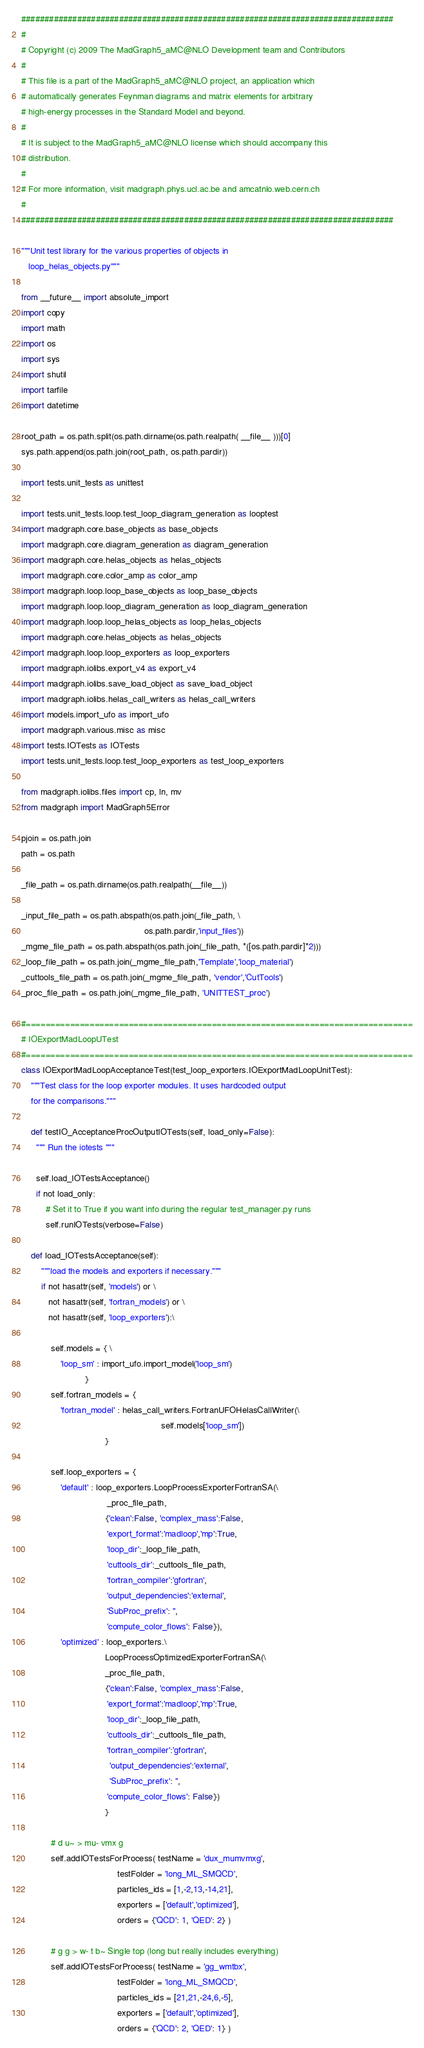Convert code to text. <code><loc_0><loc_0><loc_500><loc_500><_Python_>################################################################################
#
# Copyright (c) 2009 The MadGraph5_aMC@NLO Development team and Contributors
#
# This file is a part of the MadGraph5_aMC@NLO project, an application which 
# automatically generates Feynman diagrams and matrix elements for arbitrary
# high-energy processes in the Standard Model and beyond.
#
# It is subject to the MadGraph5_aMC@NLO license which should accompany this 
# distribution.
#
# For more information, visit madgraph.phys.ucl.ac.be and amcatnlo.web.cern.ch
#
################################################################################

"""Unit test library for the various properties of objects in 
   loop_helas_objects.py"""

from __future__ import absolute_import
import copy
import math
import os
import sys
import shutil
import tarfile
import datetime

root_path = os.path.split(os.path.dirname(os.path.realpath( __file__ )))[0]
sys.path.append(os.path.join(root_path, os.path.pardir))

import tests.unit_tests as unittest

import tests.unit_tests.loop.test_loop_diagram_generation as looptest
import madgraph.core.base_objects as base_objects
import madgraph.core.diagram_generation as diagram_generation
import madgraph.core.helas_objects as helas_objects
import madgraph.core.color_amp as color_amp
import madgraph.loop.loop_base_objects as loop_base_objects
import madgraph.loop.loop_diagram_generation as loop_diagram_generation
import madgraph.loop.loop_helas_objects as loop_helas_objects
import madgraph.core.helas_objects as helas_objects
import madgraph.loop.loop_exporters as loop_exporters
import madgraph.iolibs.export_v4 as export_v4
import madgraph.iolibs.save_load_object as save_load_object
import madgraph.iolibs.helas_call_writers as helas_call_writers
import models.import_ufo as import_ufo
import madgraph.various.misc as misc
import tests.IOTests as IOTests
import tests.unit_tests.loop.test_loop_exporters as test_loop_exporters

from madgraph.iolibs.files import cp, ln, mv
from madgraph import MadGraph5Error

pjoin = os.path.join
path = os.path

_file_path = os.path.dirname(os.path.realpath(__file__))

_input_file_path = os.path.abspath(os.path.join(_file_path, \
                                                  os.path.pardir,'input_files'))
_mgme_file_path = os.path.abspath(os.path.join(_file_path, *([os.path.pardir]*2)))
_loop_file_path = os.path.join(_mgme_file_path,'Template','loop_material')
_cuttools_file_path = os.path.join(_mgme_file_path, 'vendor','CutTools')
_proc_file_path = os.path.join(_mgme_file_path, 'UNITTEST_proc')

#===============================================================================
# IOExportMadLoopUTest
#===============================================================================
class IOExportMadLoopAcceptanceTest(test_loop_exporters.IOExportMadLoopUnitTest):
    """Test class for the loop exporter modules. It uses hardcoded output 
    for the comparisons."""

    def testIO_AcceptanceProcOutputIOTests(self, load_only=False):
      """ Run the iotests """
      
      self.load_IOTestsAcceptance()      
      if not load_only:
          # Set it to True if you want info during the regular test_manager.py runs
          self.runIOTests(verbose=False)

    def load_IOTestsAcceptance(self):
        """load the models and exporters if necessary."""
        if not hasattr(self, 'models') or \
           not hasattr(self, 'fortran_models') or \
           not hasattr(self, 'loop_exporters'):\
           
            self.models = { \
                'loop_sm' : import_ufo.import_model('loop_sm') 
                          }
            self.fortran_models = {
                'fortran_model' : helas_call_writers.FortranUFOHelasCallWriter(\
                                                         self.models['loop_sm']) 
                                  }
            
            self.loop_exporters = {
                'default' : loop_exporters.LoopProcessExporterFortranSA(\
                                   _proc_file_path,
                                  {'clean':False, 'complex_mass':False, 
                                   'export_format':'madloop','mp':True,
                                   'loop_dir':_loop_file_path,
                                   'cuttools_dir':_cuttools_file_path,
                                   'fortran_compiler':'gfortran',
                                   'output_dependencies':'external',
                                   'SubProc_prefix': '',
                                   'compute_color_flows': False}),
                'optimized' : loop_exporters.\
                                  LoopProcessOptimizedExporterFortranSA(\
                                  _proc_file_path,
                                  {'clean':False, 'complex_mass':False, 
                                   'export_format':'madloop','mp':True,
                                   'loop_dir':_loop_file_path,
                                   'cuttools_dir':_cuttools_file_path,
                                   'fortran_compiler':'gfortran',
                                    'output_dependencies':'external',
                                    'SubProc_prefix': '',
                                   'compute_color_flows': False})
                                  }

            # d u~ > mu- vmx g
            self.addIOTestsForProcess( testName = 'dux_mumvmxg',
                                       testFolder = 'long_ML_SMQCD',
                                       particles_ids = [1,-2,13,-14,21],
                                       exporters = ['default','optimized'],
                                       orders = {'QCD': 1, 'QED': 2} )

            # g g > w- t b~ Single top (long but really includes everything)
            self.addIOTestsForProcess( testName = 'gg_wmtbx',
                                       testFolder = 'long_ML_SMQCD',
                                       particles_ids = [21,21,-24,6,-5],
                                       exporters = ['default','optimized'],
                                       orders = {'QCD': 2, 'QED': 1} )

</code> 